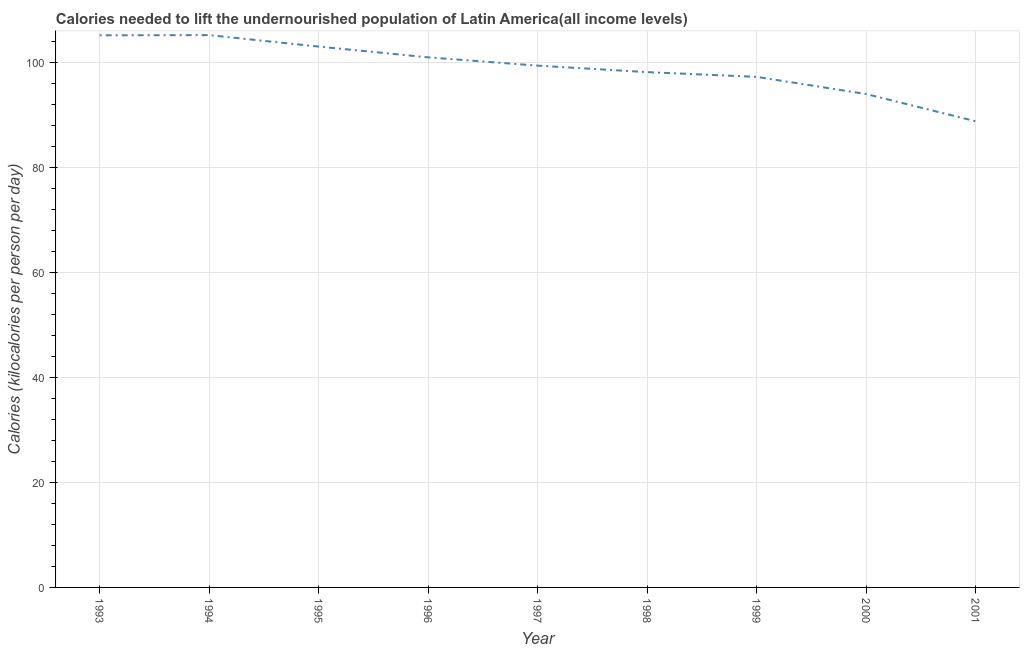What is the depth of food deficit in 1995?
Your response must be concise. 103.1. Across all years, what is the maximum depth of food deficit?
Ensure brevity in your answer.  105.28. Across all years, what is the minimum depth of food deficit?
Offer a terse response. 88.86. In which year was the depth of food deficit maximum?
Your answer should be very brief. 1994. In which year was the depth of food deficit minimum?
Provide a short and direct response. 2001. What is the sum of the depth of food deficit?
Offer a terse response. 892.58. What is the difference between the depth of food deficit in 1993 and 1999?
Your answer should be compact. 7.93. What is the average depth of food deficit per year?
Provide a succinct answer. 99.18. What is the median depth of food deficit?
Make the answer very short. 99.46. In how many years, is the depth of food deficit greater than 16 kilocalories?
Keep it short and to the point. 9. Do a majority of the years between 1999 and 1993 (inclusive) have depth of food deficit greater than 24 kilocalories?
Offer a very short reply. Yes. What is the ratio of the depth of food deficit in 1993 to that in 2000?
Your answer should be very brief. 1.12. Is the difference between the depth of food deficit in 1996 and 1999 greater than the difference between any two years?
Offer a very short reply. No. What is the difference between the highest and the second highest depth of food deficit?
Make the answer very short. 0.03. What is the difference between the highest and the lowest depth of food deficit?
Ensure brevity in your answer.  16.42. How many lines are there?
Provide a succinct answer. 1. What is the difference between two consecutive major ticks on the Y-axis?
Your response must be concise. 20. Are the values on the major ticks of Y-axis written in scientific E-notation?
Ensure brevity in your answer.  No. Does the graph contain grids?
Offer a terse response. Yes. What is the title of the graph?
Your response must be concise. Calories needed to lift the undernourished population of Latin America(all income levels). What is the label or title of the X-axis?
Give a very brief answer. Year. What is the label or title of the Y-axis?
Provide a succinct answer. Calories (kilocalories per person per day). What is the Calories (kilocalories per person per day) in 1993?
Ensure brevity in your answer.  105.25. What is the Calories (kilocalories per person per day) of 1994?
Offer a very short reply. 105.28. What is the Calories (kilocalories per person per day) of 1995?
Provide a short and direct response. 103.1. What is the Calories (kilocalories per person per day) in 1996?
Your answer should be very brief. 101.04. What is the Calories (kilocalories per person per day) in 1997?
Offer a terse response. 99.46. What is the Calories (kilocalories per person per day) in 1998?
Your answer should be compact. 98.23. What is the Calories (kilocalories per person per day) of 1999?
Provide a succinct answer. 97.32. What is the Calories (kilocalories per person per day) in 2000?
Offer a terse response. 94.05. What is the Calories (kilocalories per person per day) of 2001?
Give a very brief answer. 88.86. What is the difference between the Calories (kilocalories per person per day) in 1993 and 1994?
Make the answer very short. -0.03. What is the difference between the Calories (kilocalories per person per day) in 1993 and 1995?
Offer a very short reply. 2.15. What is the difference between the Calories (kilocalories per person per day) in 1993 and 1996?
Give a very brief answer. 4.2. What is the difference between the Calories (kilocalories per person per day) in 1993 and 1997?
Make the answer very short. 5.79. What is the difference between the Calories (kilocalories per person per day) in 1993 and 1998?
Provide a short and direct response. 7.02. What is the difference between the Calories (kilocalories per person per day) in 1993 and 1999?
Offer a very short reply. 7.93. What is the difference between the Calories (kilocalories per person per day) in 1993 and 2000?
Offer a terse response. 11.2. What is the difference between the Calories (kilocalories per person per day) in 1993 and 2001?
Your answer should be compact. 16.39. What is the difference between the Calories (kilocalories per person per day) in 1994 and 1995?
Offer a terse response. 2.18. What is the difference between the Calories (kilocalories per person per day) in 1994 and 1996?
Your response must be concise. 4.23. What is the difference between the Calories (kilocalories per person per day) in 1994 and 1997?
Provide a short and direct response. 5.82. What is the difference between the Calories (kilocalories per person per day) in 1994 and 1998?
Make the answer very short. 7.05. What is the difference between the Calories (kilocalories per person per day) in 1994 and 1999?
Your answer should be very brief. 7.96. What is the difference between the Calories (kilocalories per person per day) in 1994 and 2000?
Your answer should be compact. 11.23. What is the difference between the Calories (kilocalories per person per day) in 1994 and 2001?
Ensure brevity in your answer.  16.42. What is the difference between the Calories (kilocalories per person per day) in 1995 and 1996?
Make the answer very short. 2.05. What is the difference between the Calories (kilocalories per person per day) in 1995 and 1997?
Ensure brevity in your answer.  3.64. What is the difference between the Calories (kilocalories per person per day) in 1995 and 1998?
Your response must be concise. 4.87. What is the difference between the Calories (kilocalories per person per day) in 1995 and 1999?
Your answer should be very brief. 5.78. What is the difference between the Calories (kilocalories per person per day) in 1995 and 2000?
Give a very brief answer. 9.05. What is the difference between the Calories (kilocalories per person per day) in 1995 and 2001?
Provide a short and direct response. 14.24. What is the difference between the Calories (kilocalories per person per day) in 1996 and 1997?
Make the answer very short. 1.58. What is the difference between the Calories (kilocalories per person per day) in 1996 and 1998?
Keep it short and to the point. 2.82. What is the difference between the Calories (kilocalories per person per day) in 1996 and 1999?
Give a very brief answer. 3.72. What is the difference between the Calories (kilocalories per person per day) in 1996 and 2000?
Keep it short and to the point. 7. What is the difference between the Calories (kilocalories per person per day) in 1996 and 2001?
Provide a short and direct response. 12.18. What is the difference between the Calories (kilocalories per person per day) in 1997 and 1998?
Offer a very short reply. 1.24. What is the difference between the Calories (kilocalories per person per day) in 1997 and 1999?
Give a very brief answer. 2.14. What is the difference between the Calories (kilocalories per person per day) in 1997 and 2000?
Provide a short and direct response. 5.41. What is the difference between the Calories (kilocalories per person per day) in 1997 and 2001?
Offer a terse response. 10.6. What is the difference between the Calories (kilocalories per person per day) in 1998 and 1999?
Your answer should be compact. 0.91. What is the difference between the Calories (kilocalories per person per day) in 1998 and 2000?
Keep it short and to the point. 4.18. What is the difference between the Calories (kilocalories per person per day) in 1998 and 2001?
Your answer should be compact. 9.36. What is the difference between the Calories (kilocalories per person per day) in 1999 and 2000?
Offer a very short reply. 3.27. What is the difference between the Calories (kilocalories per person per day) in 1999 and 2001?
Offer a terse response. 8.46. What is the difference between the Calories (kilocalories per person per day) in 2000 and 2001?
Provide a succinct answer. 5.19. What is the ratio of the Calories (kilocalories per person per day) in 1993 to that in 1994?
Your response must be concise. 1. What is the ratio of the Calories (kilocalories per person per day) in 1993 to that in 1995?
Your response must be concise. 1.02. What is the ratio of the Calories (kilocalories per person per day) in 1993 to that in 1996?
Give a very brief answer. 1.04. What is the ratio of the Calories (kilocalories per person per day) in 1993 to that in 1997?
Your answer should be compact. 1.06. What is the ratio of the Calories (kilocalories per person per day) in 1993 to that in 1998?
Ensure brevity in your answer.  1.07. What is the ratio of the Calories (kilocalories per person per day) in 1993 to that in 1999?
Make the answer very short. 1.08. What is the ratio of the Calories (kilocalories per person per day) in 1993 to that in 2000?
Your answer should be very brief. 1.12. What is the ratio of the Calories (kilocalories per person per day) in 1993 to that in 2001?
Provide a short and direct response. 1.18. What is the ratio of the Calories (kilocalories per person per day) in 1994 to that in 1995?
Your answer should be compact. 1.02. What is the ratio of the Calories (kilocalories per person per day) in 1994 to that in 1996?
Provide a succinct answer. 1.04. What is the ratio of the Calories (kilocalories per person per day) in 1994 to that in 1997?
Your answer should be compact. 1.06. What is the ratio of the Calories (kilocalories per person per day) in 1994 to that in 1998?
Your answer should be compact. 1.07. What is the ratio of the Calories (kilocalories per person per day) in 1994 to that in 1999?
Provide a short and direct response. 1.08. What is the ratio of the Calories (kilocalories per person per day) in 1994 to that in 2000?
Offer a terse response. 1.12. What is the ratio of the Calories (kilocalories per person per day) in 1994 to that in 2001?
Give a very brief answer. 1.19. What is the ratio of the Calories (kilocalories per person per day) in 1995 to that in 1996?
Your answer should be very brief. 1.02. What is the ratio of the Calories (kilocalories per person per day) in 1995 to that in 1997?
Give a very brief answer. 1.04. What is the ratio of the Calories (kilocalories per person per day) in 1995 to that in 1998?
Give a very brief answer. 1.05. What is the ratio of the Calories (kilocalories per person per day) in 1995 to that in 1999?
Your response must be concise. 1.06. What is the ratio of the Calories (kilocalories per person per day) in 1995 to that in 2000?
Provide a short and direct response. 1.1. What is the ratio of the Calories (kilocalories per person per day) in 1995 to that in 2001?
Your answer should be very brief. 1.16. What is the ratio of the Calories (kilocalories per person per day) in 1996 to that in 1999?
Your answer should be very brief. 1.04. What is the ratio of the Calories (kilocalories per person per day) in 1996 to that in 2000?
Ensure brevity in your answer.  1.07. What is the ratio of the Calories (kilocalories per person per day) in 1996 to that in 2001?
Provide a short and direct response. 1.14. What is the ratio of the Calories (kilocalories per person per day) in 1997 to that in 1998?
Your response must be concise. 1.01. What is the ratio of the Calories (kilocalories per person per day) in 1997 to that in 1999?
Provide a succinct answer. 1.02. What is the ratio of the Calories (kilocalories per person per day) in 1997 to that in 2000?
Your answer should be very brief. 1.06. What is the ratio of the Calories (kilocalories per person per day) in 1997 to that in 2001?
Offer a terse response. 1.12. What is the ratio of the Calories (kilocalories per person per day) in 1998 to that in 2000?
Provide a succinct answer. 1.04. What is the ratio of the Calories (kilocalories per person per day) in 1998 to that in 2001?
Keep it short and to the point. 1.1. What is the ratio of the Calories (kilocalories per person per day) in 1999 to that in 2000?
Offer a very short reply. 1.03. What is the ratio of the Calories (kilocalories per person per day) in 1999 to that in 2001?
Offer a terse response. 1.09. What is the ratio of the Calories (kilocalories per person per day) in 2000 to that in 2001?
Provide a short and direct response. 1.06. 